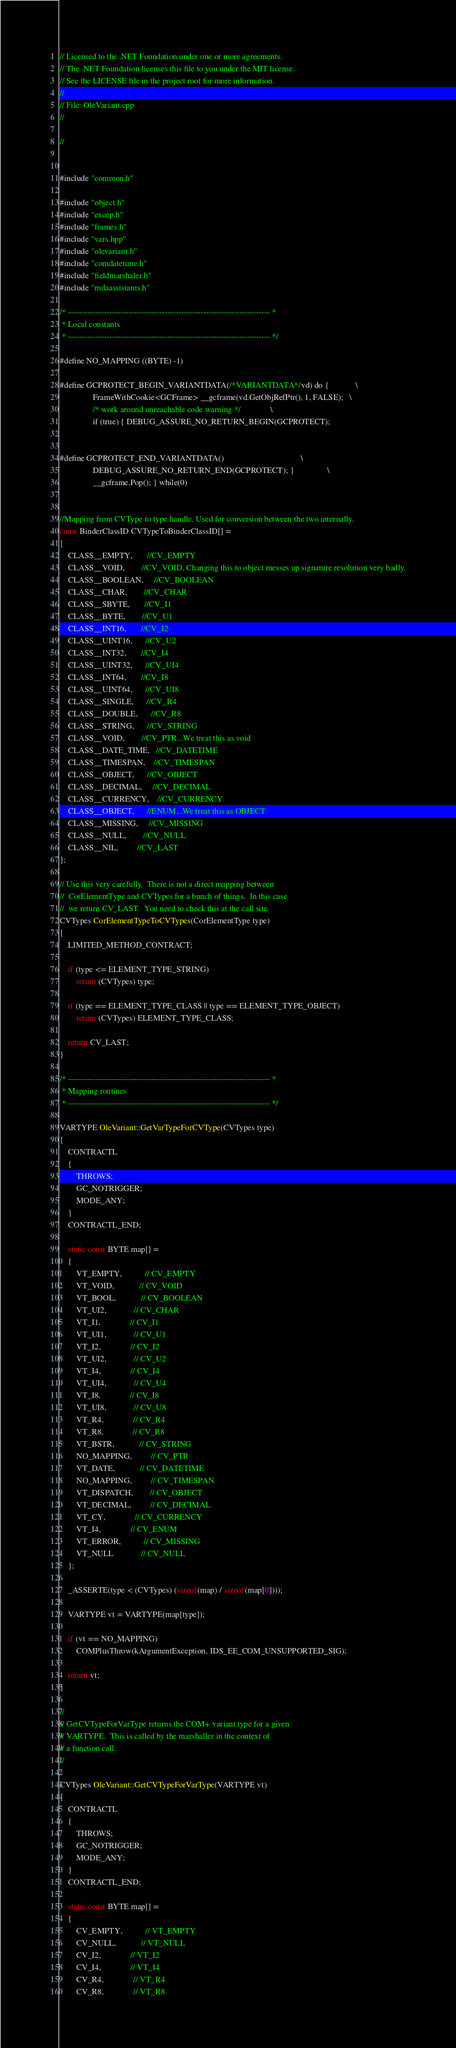Convert code to text. <code><loc_0><loc_0><loc_500><loc_500><_C++_>// Licensed to the .NET Foundation under one or more agreements.
// The .NET Foundation licenses this file to you under the MIT license.
// See the LICENSE file in the project root for more information.
// 
// File: OleVariant.cpp
// 

//


#include "common.h"

#include "object.h"
#include "excep.h"
#include "frames.h"
#include "vars.hpp"
#include "olevariant.h"
#include "comdatetime.h"
#include "fieldmarshaler.h"
#include "mdaassistants.h"

/* ------------------------------------------------------------------------- *
 * Local constants
 * ------------------------------------------------------------------------- */

#define NO_MAPPING ((BYTE) -1)

#define GCPROTECT_BEGIN_VARIANTDATA(/*VARIANTDATA*/vd) do {             \
                FrameWithCookie<GCFrame> __gcframe(vd.GetObjRefPtr(), 1, FALSE);   \
                /* work around unreachable code warning */              \
                if (true) { DEBUG_ASSURE_NO_RETURN_BEGIN(GCPROTECT);


#define GCPROTECT_END_VARIANTDATA()                                     \
                DEBUG_ASSURE_NO_RETURN_END(GCPROTECT); }                \
                __gcframe.Pop(); } while(0)


//Mapping from CVType to type handle. Used for conversion between the two internally.
const BinderClassID CVTypeToBinderClassID[] = 
{
    CLASS__EMPTY,       //CV_EMPTY
    CLASS__VOID,        //CV_VOID, Changing this to object messes up signature resolution very badly.
    CLASS__BOOLEAN,     //CV_BOOLEAN
    CLASS__CHAR,        //CV_CHAR
    CLASS__SBYTE,       //CV_I1
    CLASS__BYTE,        //CV_U1
    CLASS__INT16,       //CV_I2
    CLASS__UINT16,      //CV_U2
    CLASS__INT32,       //CV_I4
    CLASS__UINT32,      //CV_UI4
    CLASS__INT64,       //CV_I8
    CLASS__UINT64,      //CV_UI8
    CLASS__SINGLE,      //CV_R4   
    CLASS__DOUBLE,      //CV_R8   
    CLASS__STRING,      //CV_STRING
    CLASS__VOID,        //CV_PTR...We treat this as void
    CLASS__DATE_TIME,   //CV_DATETIME
    CLASS__TIMESPAN,    //CV_TIMESPAN
    CLASS__OBJECT,      //CV_OBJECT
    CLASS__DECIMAL,     //CV_DECIMAL
    CLASS__CURRENCY,    //CV_CURRENCY
    CLASS__OBJECT,      //ENUM...We treat this as OBJECT
    CLASS__MISSING,     //CV_MISSING
    CLASS__NULL,        //CV_NULL
    CLASS__NIL,         //CV_LAST
};

// Use this very carefully.  There is not a direct mapping between
//  CorElementType and CVTypes for a bunch of things.  In this case
//  we return CV_LAST.  You need to check this at the call site.
CVTypes CorElementTypeToCVTypes(CorElementType type)
{
    LIMITED_METHOD_CONTRACT;
    
    if (type <= ELEMENT_TYPE_STRING)
        return (CVTypes) type;
    
    if (type == ELEMENT_TYPE_CLASS || type == ELEMENT_TYPE_OBJECT)
        return (CVTypes) ELEMENT_TYPE_CLASS;
    
    return CV_LAST;
}

/* ------------------------------------------------------------------------- *
 * Mapping routines
 * ------------------------------------------------------------------------- */

VARTYPE OleVariant::GetVarTypeForCVType(CVTypes type)
{
    CONTRACTL
    {
        THROWS;
        GC_NOTRIGGER;
        MODE_ANY;
    }
    CONTRACTL_END;
    
    static const BYTE map[] = 
    {
        VT_EMPTY,           // CV_EMPTY
        VT_VOID,            // CV_VOID
        VT_BOOL,            // CV_BOOLEAN
        VT_UI2,             // CV_CHAR
        VT_I1,              // CV_I1
        VT_UI1,             // CV_U1
        VT_I2,              // CV_I2
        VT_UI2,             // CV_U2
        VT_I4,              // CV_I4
        VT_UI4,             // CV_U4
        VT_I8,              // CV_I8
        VT_UI8,             // CV_U8
        VT_R4,              // CV_R4
        VT_R8,              // CV_R8
        VT_BSTR,            // CV_STRING
        NO_MAPPING,         // CV_PTR
        VT_DATE,            // CV_DATETIME
        NO_MAPPING,         // CV_TIMESPAN
        VT_DISPATCH,        // CV_OBJECT
        VT_DECIMAL,         // CV_DECIMAL
        VT_CY,              // CV_CURRENCY
        VT_I4,              // CV_ENUM
        VT_ERROR,           // CV_MISSING
        VT_NULL             // CV_NULL
    };

    _ASSERTE(type < (CVTypes) (sizeof(map) / sizeof(map[0])));

    VARTYPE vt = VARTYPE(map[type]);

    if (vt == NO_MAPPING)
        COMPlusThrow(kArgumentException, IDS_EE_COM_UNSUPPORTED_SIG);

    return vt;
}

//
// GetCVTypeForVarType returns the COM+ variant type for a given 
// VARTYPE.  This is called by the marshaller in the context of
// a function call.
//

CVTypes OleVariant::GetCVTypeForVarType(VARTYPE vt)
{
    CONTRACTL
    {
        THROWS;
        GC_NOTRIGGER;
        MODE_ANY;
    }
    CONTRACTL_END;
    
    static const BYTE map[] = 
    {
        CV_EMPTY,           // VT_EMPTY
        CV_NULL,            // VT_NULL
        CV_I2,              // VT_I2
        CV_I4,              // VT_I4
        CV_R4,              // VT_R4
        CV_R8,              // VT_R8</code> 